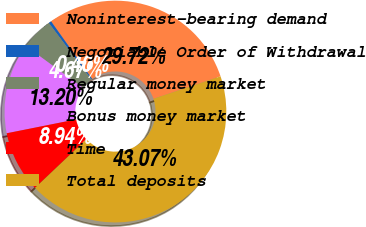<chart> <loc_0><loc_0><loc_500><loc_500><pie_chart><fcel>Noninterest-bearing demand<fcel>Negotiable Order of Withdrawal<fcel>Regular money market<fcel>Bonus money market<fcel>Time<fcel>Total deposits<nl><fcel>29.72%<fcel>0.4%<fcel>4.67%<fcel>13.2%<fcel>8.94%<fcel>43.07%<nl></chart> 